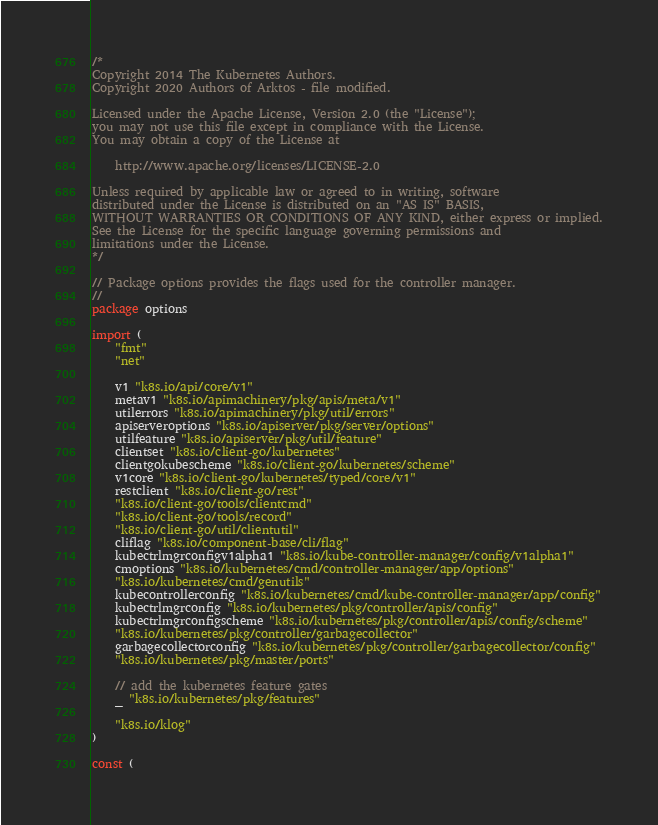Convert code to text. <code><loc_0><loc_0><loc_500><loc_500><_Go_>/*
Copyright 2014 The Kubernetes Authors.
Copyright 2020 Authors of Arktos - file modified.

Licensed under the Apache License, Version 2.0 (the "License");
you may not use this file except in compliance with the License.
You may obtain a copy of the License at

    http://www.apache.org/licenses/LICENSE-2.0

Unless required by applicable law or agreed to in writing, software
distributed under the License is distributed on an "AS IS" BASIS,
WITHOUT WARRANTIES OR CONDITIONS OF ANY KIND, either express or implied.
See the License for the specific language governing permissions and
limitations under the License.
*/

// Package options provides the flags used for the controller manager.
//
package options

import (
	"fmt"
	"net"

	v1 "k8s.io/api/core/v1"
	metav1 "k8s.io/apimachinery/pkg/apis/meta/v1"
	utilerrors "k8s.io/apimachinery/pkg/util/errors"
	apiserveroptions "k8s.io/apiserver/pkg/server/options"
	utilfeature "k8s.io/apiserver/pkg/util/feature"
	clientset "k8s.io/client-go/kubernetes"
	clientgokubescheme "k8s.io/client-go/kubernetes/scheme"
	v1core "k8s.io/client-go/kubernetes/typed/core/v1"
	restclient "k8s.io/client-go/rest"
	"k8s.io/client-go/tools/clientcmd"
	"k8s.io/client-go/tools/record"
	"k8s.io/client-go/util/clientutil"
	cliflag "k8s.io/component-base/cli/flag"
	kubectrlmgrconfigv1alpha1 "k8s.io/kube-controller-manager/config/v1alpha1"
	cmoptions "k8s.io/kubernetes/cmd/controller-manager/app/options"
	"k8s.io/kubernetes/cmd/genutils"
	kubecontrollerconfig "k8s.io/kubernetes/cmd/kube-controller-manager/app/config"
	kubectrlmgrconfig "k8s.io/kubernetes/pkg/controller/apis/config"
	kubectrlmgrconfigscheme "k8s.io/kubernetes/pkg/controller/apis/config/scheme"
	"k8s.io/kubernetes/pkg/controller/garbagecollector"
	garbagecollectorconfig "k8s.io/kubernetes/pkg/controller/garbagecollector/config"
	"k8s.io/kubernetes/pkg/master/ports"

	// add the kubernetes feature gates
	_ "k8s.io/kubernetes/pkg/features"

	"k8s.io/klog"
)

const (</code> 